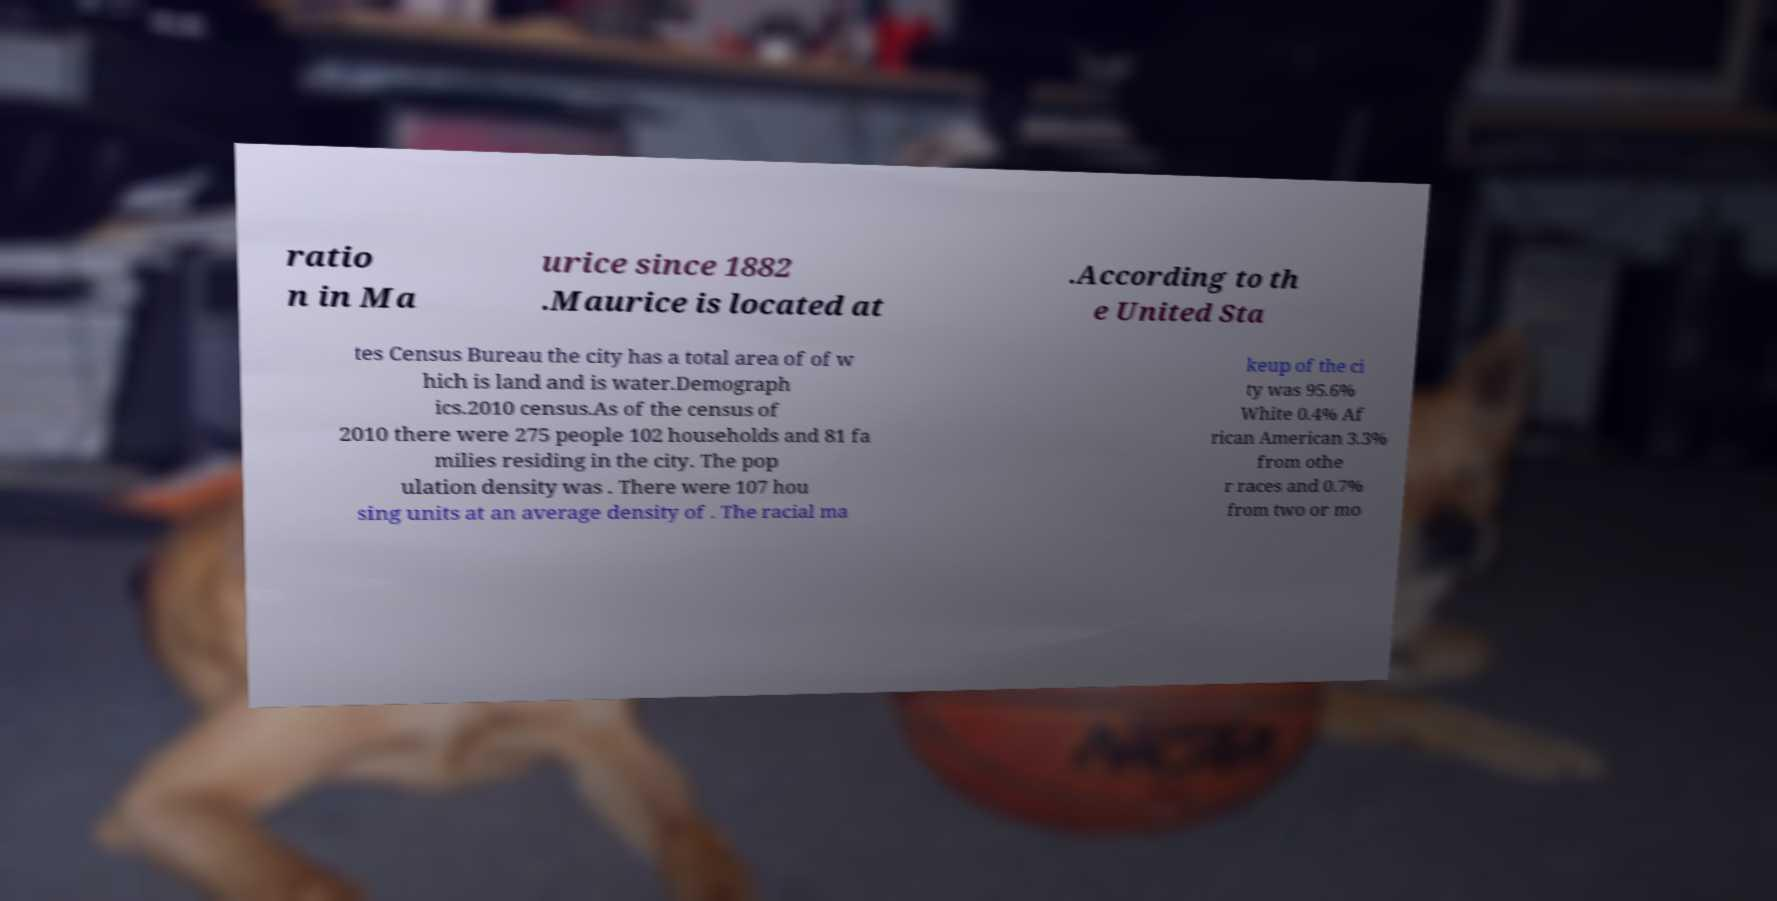Could you assist in decoding the text presented in this image and type it out clearly? ratio n in Ma urice since 1882 .Maurice is located at .According to th e United Sta tes Census Bureau the city has a total area of of w hich is land and is water.Demograph ics.2010 census.As of the census of 2010 there were 275 people 102 households and 81 fa milies residing in the city. The pop ulation density was . There were 107 hou sing units at an average density of . The racial ma keup of the ci ty was 95.6% White 0.4% Af rican American 3.3% from othe r races and 0.7% from two or mo 